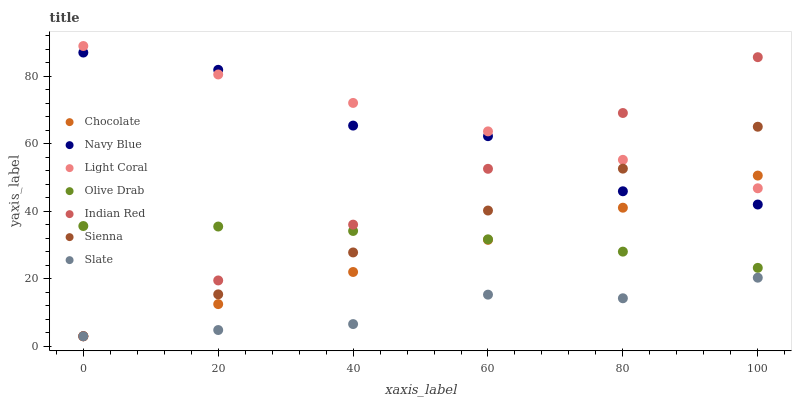Does Slate have the minimum area under the curve?
Answer yes or no. Yes. Does Light Coral have the maximum area under the curve?
Answer yes or no. Yes. Does Navy Blue have the minimum area under the curve?
Answer yes or no. No. Does Navy Blue have the maximum area under the curve?
Answer yes or no. No. Is Sienna the smoothest?
Answer yes or no. Yes. Is Navy Blue the roughest?
Answer yes or no. Yes. Is Slate the smoothest?
Answer yes or no. No. Is Slate the roughest?
Answer yes or no. No. Does Sienna have the lowest value?
Answer yes or no. Yes. Does Navy Blue have the lowest value?
Answer yes or no. No. Does Light Coral have the highest value?
Answer yes or no. Yes. Does Navy Blue have the highest value?
Answer yes or no. No. Is Olive Drab less than Navy Blue?
Answer yes or no. Yes. Is Navy Blue greater than Olive Drab?
Answer yes or no. Yes. Does Indian Red intersect Navy Blue?
Answer yes or no. Yes. Is Indian Red less than Navy Blue?
Answer yes or no. No. Is Indian Red greater than Navy Blue?
Answer yes or no. No. Does Olive Drab intersect Navy Blue?
Answer yes or no. No. 